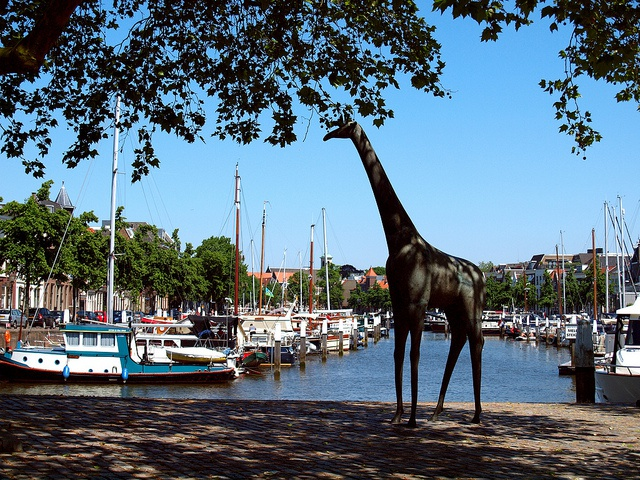Describe the objects in this image and their specific colors. I can see giraffe in black and gray tones, boat in black, lightblue, gray, and white tones, boat in black, white, teal, and blue tones, boat in black, white, and gray tones, and boat in black, white, gray, and darkgray tones in this image. 